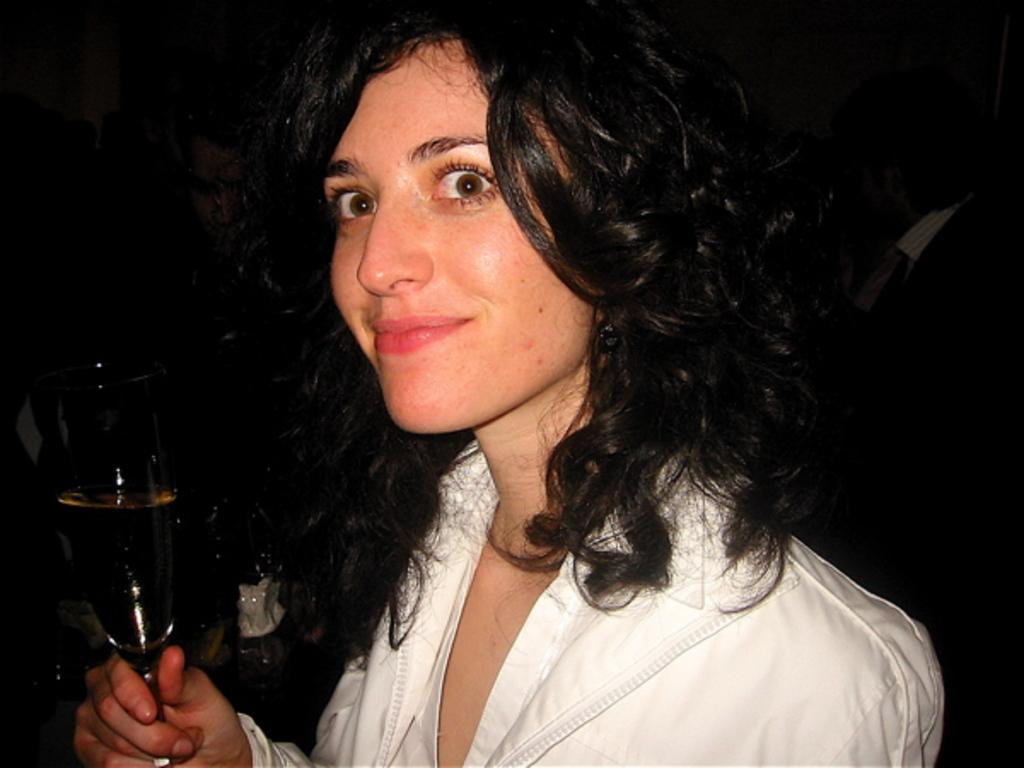What is the woman in the image wearing? The woman is wearing a white dress. What expression does the woman have? The woman is smiling. What object is the woman holding in the image? The woman is holding a wine glass. What type of flower can be seen growing in the woman's hair in the image? There is no flower visible in the woman's hair in the image. What type of liquid is the woman drinking from the wine glass? The image does not show the woman drinking from the wine glass, so it cannot be determined what type of liquid is in the glass. 